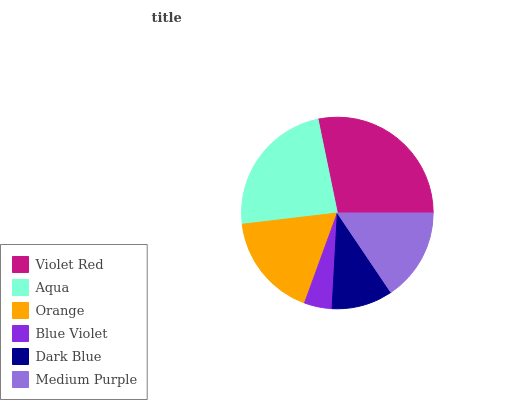Is Blue Violet the minimum?
Answer yes or no. Yes. Is Violet Red the maximum?
Answer yes or no. Yes. Is Aqua the minimum?
Answer yes or no. No. Is Aqua the maximum?
Answer yes or no. No. Is Violet Red greater than Aqua?
Answer yes or no. Yes. Is Aqua less than Violet Red?
Answer yes or no. Yes. Is Aqua greater than Violet Red?
Answer yes or no. No. Is Violet Red less than Aqua?
Answer yes or no. No. Is Orange the high median?
Answer yes or no. Yes. Is Medium Purple the low median?
Answer yes or no. Yes. Is Blue Violet the high median?
Answer yes or no. No. Is Violet Red the low median?
Answer yes or no. No. 